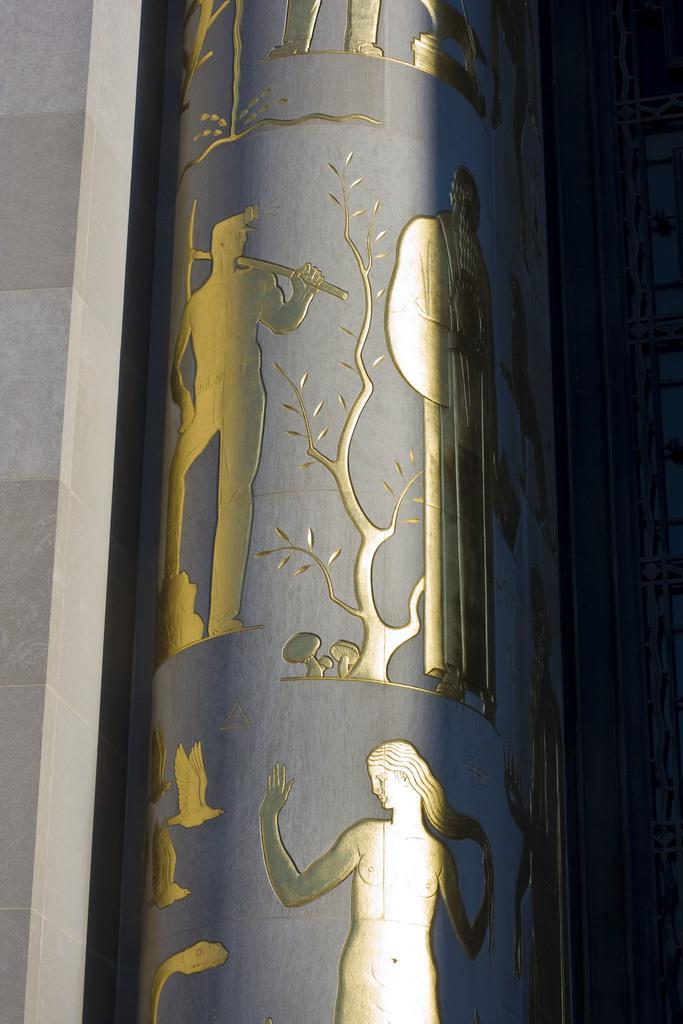What is the main subject of the image? The main subject of the image is a building's wall. What can be seen in the center of the image? There are statues in the center of the image. Can you describe the statues in more detail? One of the statues represents a person, and there is a statue of a hammer in the image. Are there any specific characteristics of the statues? Yes, there is a statue made from a gold color in the image. What type of card is being used by the authority figure in the image? There is no card or authority figure present in the image. What is the zinc content of the gold-colored statue in the image? There is no information about the zinc content of the statue, as it is only mentioned to be gold in color. 